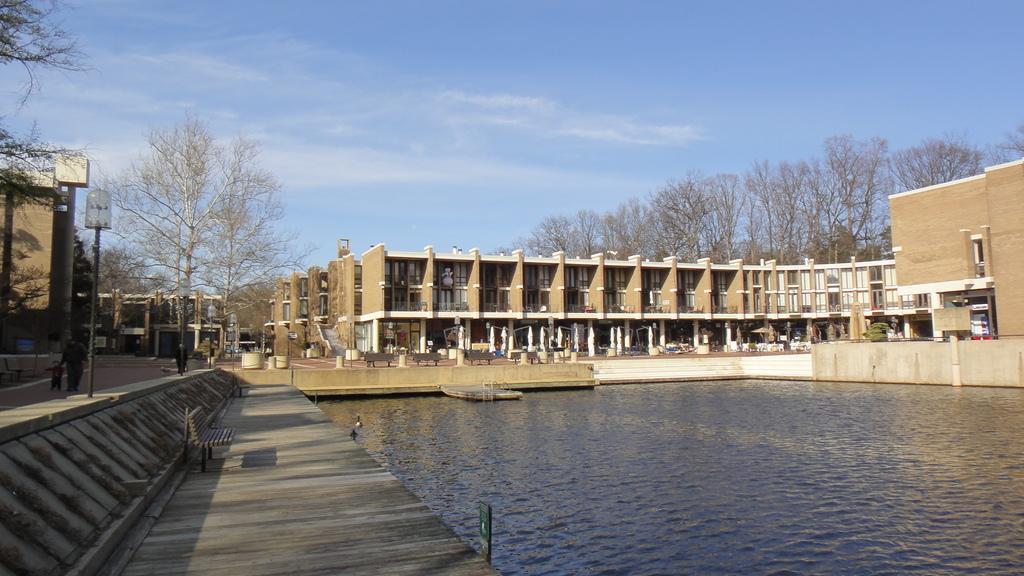Describe this image in one or two sentences. In this image we can see building, benches, stairs, water, trees, sky and clouds. 